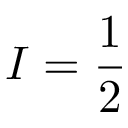<formula> <loc_0><loc_0><loc_500><loc_500>I = { \frac { 1 } { 2 } }</formula> 